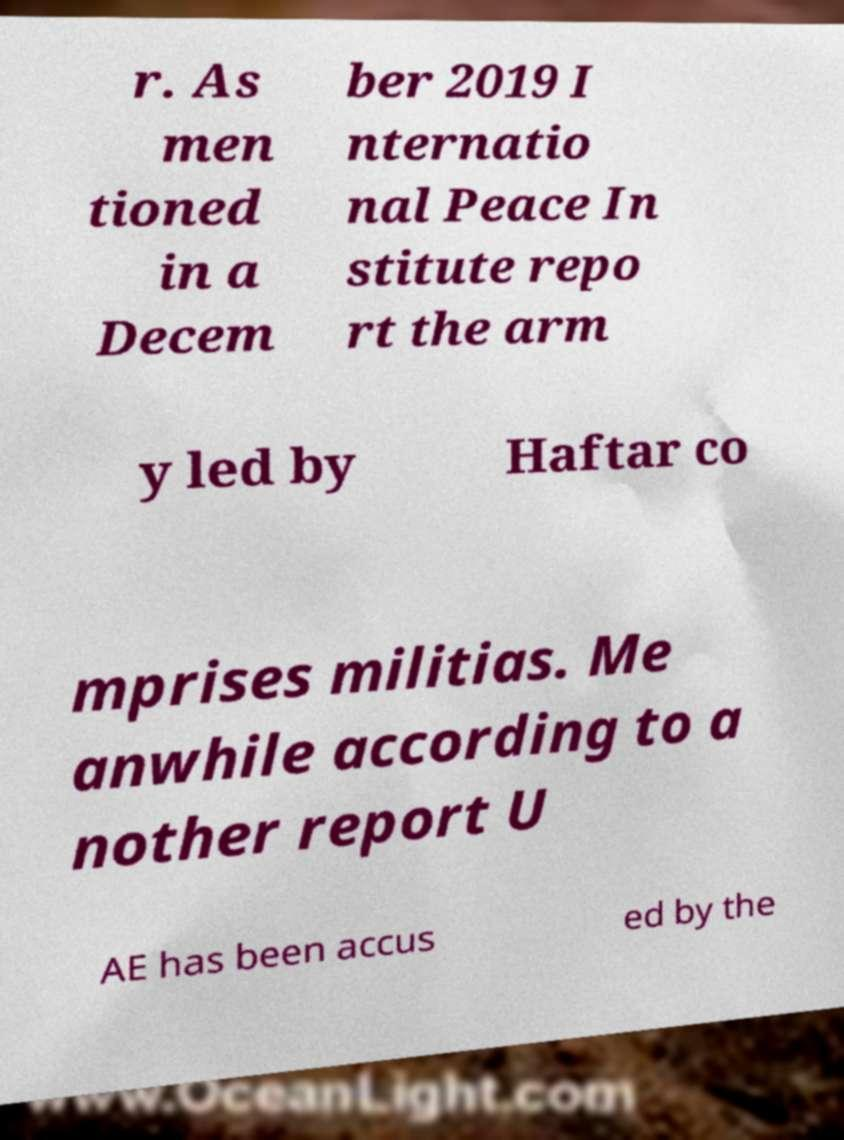Could you extract and type out the text from this image? r. As men tioned in a Decem ber 2019 I nternatio nal Peace In stitute repo rt the arm y led by Haftar co mprises militias. Me anwhile according to a nother report U AE has been accus ed by the 